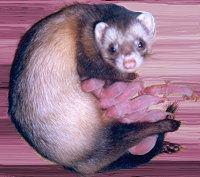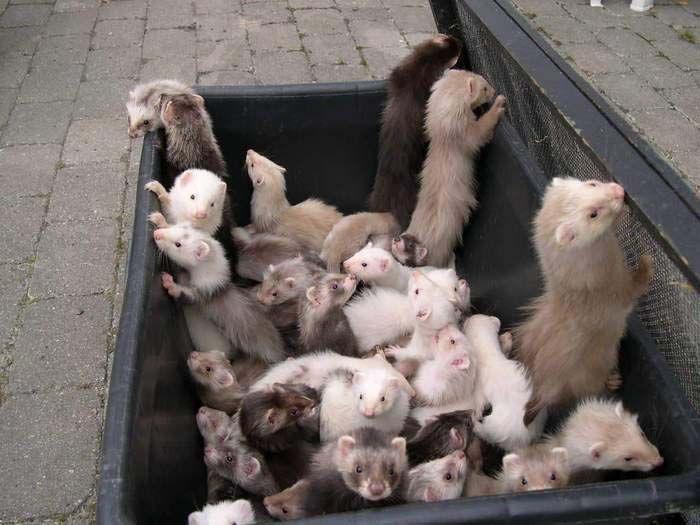The first image is the image on the left, the second image is the image on the right. For the images shown, is this caption "At least one baby ferret is being held by a human hand." true? Answer yes or no. No. The first image is the image on the left, the second image is the image on the right. Analyze the images presented: Is the assertion "At least four ferrets are in the same container in one image." valid? Answer yes or no. Yes. 